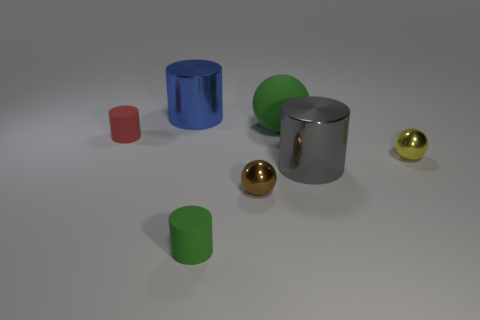The thing that is the same color as the matte ball is what size?
Your response must be concise. Small. There is a large gray object that is the same shape as the large blue metal thing; what material is it?
Ensure brevity in your answer.  Metal. Is the number of big gray metal cylinders that are to the right of the big gray metal object less than the number of large yellow rubber balls?
Ensure brevity in your answer.  No. Do the large metallic thing that is on the right side of the blue cylinder and the blue object have the same shape?
Offer a terse response. Yes. There is a green cylinder that is made of the same material as the big ball; what size is it?
Offer a terse response. Small. What is the material of the small cylinder that is behind the small sphere that is in front of the big shiny object that is in front of the yellow object?
Give a very brief answer. Rubber. Are there fewer shiny balls than blue metal cylinders?
Provide a succinct answer. No. Do the red thing and the green cylinder have the same material?
Your response must be concise. Yes. There is another rubber thing that is the same color as the big matte object; what is its shape?
Your answer should be very brief. Cylinder. Is the color of the tiny cylinder that is behind the green rubber cylinder the same as the large ball?
Give a very brief answer. No. 